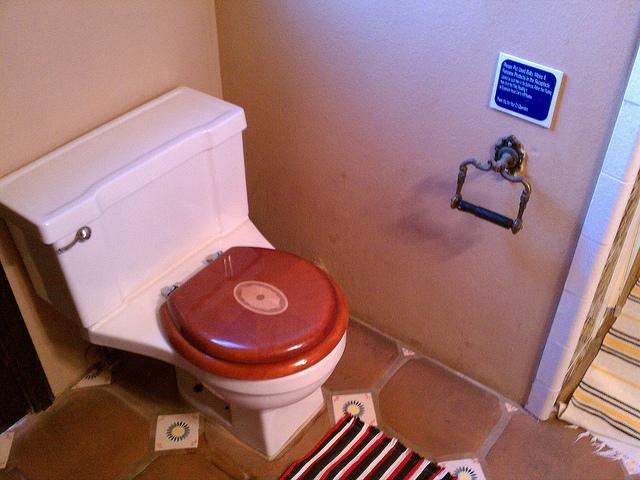How many rugs are laying on the floor?
Give a very brief answer. 2. Should the toilet paper dispenser be reloaded?
Give a very brief answer. Yes. What's in this room?
Quick response, please. Toilet. 